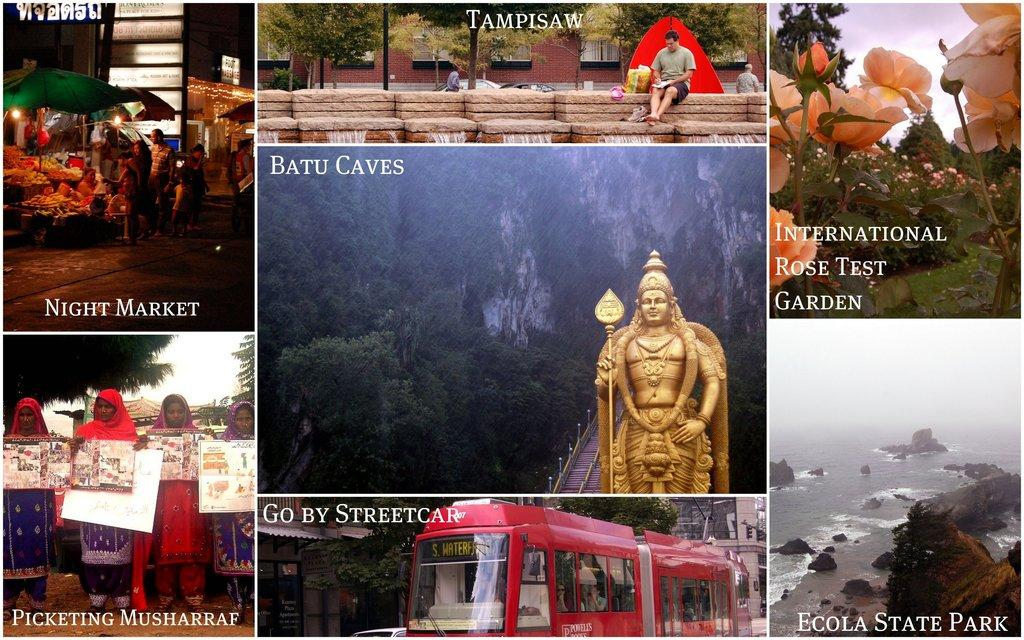<image>
Relay a brief, clear account of the picture shown. A series of images, like Batu Caves, arranged in a collage. 